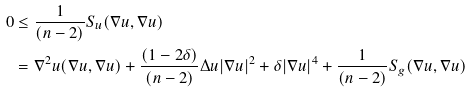<formula> <loc_0><loc_0><loc_500><loc_500>0 & \leq \frac { 1 } { ( n - 2 ) } S _ { u } ( \nabla u , \nabla u ) \\ & = \nabla ^ { 2 } u ( \nabla u , \nabla u ) + \frac { ( 1 - 2 \delta ) } { ( n - 2 ) } \Delta u | \nabla u | ^ { 2 } + \delta | \nabla u | ^ { 4 } + \frac { 1 } { ( n - 2 ) } S _ { g } ( \nabla u , \nabla u )</formula> 